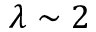Convert formula to latex. <formula><loc_0><loc_0><loc_500><loc_500>\lambda \sim 2</formula> 